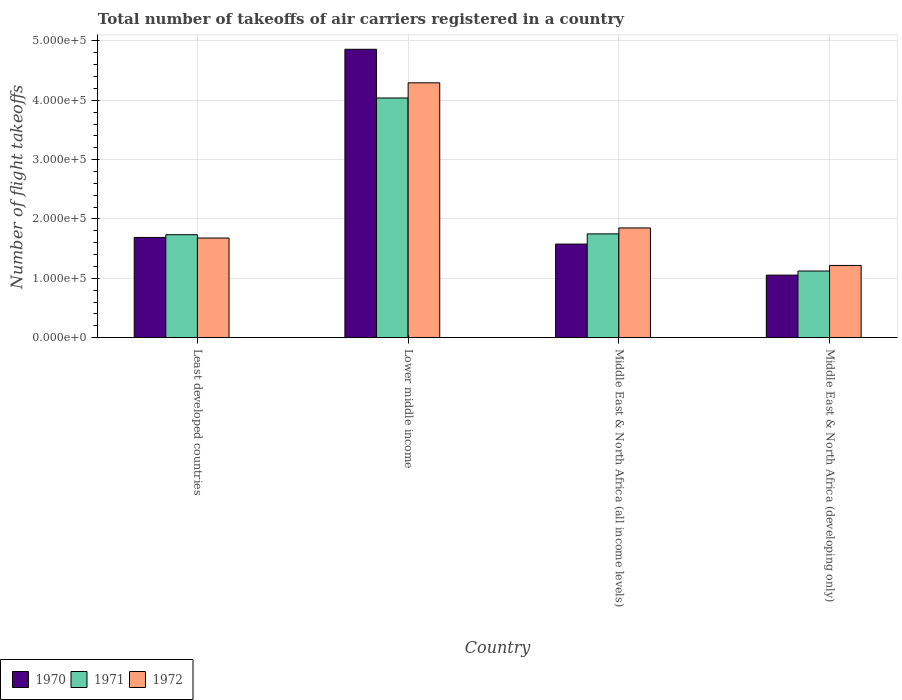Are the number of bars per tick equal to the number of legend labels?
Offer a terse response. Yes. Are the number of bars on each tick of the X-axis equal?
Offer a terse response. Yes. How many bars are there on the 2nd tick from the left?
Your answer should be very brief. 3. How many bars are there on the 1st tick from the right?
Offer a terse response. 3. What is the label of the 1st group of bars from the left?
Your answer should be very brief. Least developed countries. What is the total number of flight takeoffs in 1971 in Least developed countries?
Your answer should be very brief. 1.74e+05. Across all countries, what is the maximum total number of flight takeoffs in 1972?
Provide a short and direct response. 4.30e+05. Across all countries, what is the minimum total number of flight takeoffs in 1971?
Provide a succinct answer. 1.12e+05. In which country was the total number of flight takeoffs in 1972 maximum?
Your answer should be very brief. Lower middle income. In which country was the total number of flight takeoffs in 1970 minimum?
Keep it short and to the point. Middle East & North Africa (developing only). What is the total total number of flight takeoffs in 1970 in the graph?
Offer a terse response. 9.18e+05. What is the difference between the total number of flight takeoffs in 1971 in Middle East & North Africa (all income levels) and that in Middle East & North Africa (developing only)?
Provide a short and direct response. 6.26e+04. What is the difference between the total number of flight takeoffs in 1971 in Middle East & North Africa (developing only) and the total number of flight takeoffs in 1970 in Lower middle income?
Your answer should be very brief. -3.74e+05. What is the average total number of flight takeoffs in 1971 per country?
Keep it short and to the point. 2.16e+05. What is the difference between the total number of flight takeoffs of/in 1970 and total number of flight takeoffs of/in 1972 in Middle East & North Africa (all income levels)?
Provide a succinct answer. -2.72e+04. What is the ratio of the total number of flight takeoffs in 1970 in Lower middle income to that in Middle East & North Africa (all income levels)?
Offer a terse response. 3.08. Is the total number of flight takeoffs in 1972 in Least developed countries less than that in Middle East & North Africa (developing only)?
Offer a terse response. No. Is the difference between the total number of flight takeoffs in 1970 in Lower middle income and Middle East & North Africa (developing only) greater than the difference between the total number of flight takeoffs in 1972 in Lower middle income and Middle East & North Africa (developing only)?
Offer a very short reply. Yes. What is the difference between the highest and the second highest total number of flight takeoffs in 1970?
Your response must be concise. 3.17e+05. What is the difference between the highest and the lowest total number of flight takeoffs in 1970?
Give a very brief answer. 3.81e+05. In how many countries, is the total number of flight takeoffs in 1970 greater than the average total number of flight takeoffs in 1970 taken over all countries?
Your answer should be very brief. 1. Is the sum of the total number of flight takeoffs in 1971 in Lower middle income and Middle East & North Africa (all income levels) greater than the maximum total number of flight takeoffs in 1970 across all countries?
Your answer should be compact. Yes. What does the 3rd bar from the right in Least developed countries represents?
Offer a very short reply. 1970. Is it the case that in every country, the sum of the total number of flight takeoffs in 1971 and total number of flight takeoffs in 1970 is greater than the total number of flight takeoffs in 1972?
Your response must be concise. Yes. How many bars are there?
Your response must be concise. 12. What is the difference between two consecutive major ticks on the Y-axis?
Provide a short and direct response. 1.00e+05. Are the values on the major ticks of Y-axis written in scientific E-notation?
Make the answer very short. Yes. Does the graph contain any zero values?
Offer a terse response. No. Does the graph contain grids?
Your answer should be very brief. Yes. Where does the legend appear in the graph?
Make the answer very short. Bottom left. How many legend labels are there?
Provide a short and direct response. 3. How are the legend labels stacked?
Give a very brief answer. Horizontal. What is the title of the graph?
Make the answer very short. Total number of takeoffs of air carriers registered in a country. What is the label or title of the X-axis?
Offer a terse response. Country. What is the label or title of the Y-axis?
Provide a short and direct response. Number of flight takeoffs. What is the Number of flight takeoffs in 1970 in Least developed countries?
Offer a terse response. 1.69e+05. What is the Number of flight takeoffs in 1971 in Least developed countries?
Your answer should be very brief. 1.74e+05. What is the Number of flight takeoffs of 1972 in Least developed countries?
Offer a very short reply. 1.68e+05. What is the Number of flight takeoffs in 1970 in Lower middle income?
Give a very brief answer. 4.86e+05. What is the Number of flight takeoffs of 1971 in Lower middle income?
Make the answer very short. 4.04e+05. What is the Number of flight takeoffs of 1972 in Lower middle income?
Give a very brief answer. 4.30e+05. What is the Number of flight takeoffs of 1970 in Middle East & North Africa (all income levels)?
Keep it short and to the point. 1.58e+05. What is the Number of flight takeoffs of 1971 in Middle East & North Africa (all income levels)?
Make the answer very short. 1.75e+05. What is the Number of flight takeoffs in 1972 in Middle East & North Africa (all income levels)?
Keep it short and to the point. 1.85e+05. What is the Number of flight takeoffs in 1970 in Middle East & North Africa (developing only)?
Ensure brevity in your answer.  1.05e+05. What is the Number of flight takeoffs in 1971 in Middle East & North Africa (developing only)?
Ensure brevity in your answer.  1.12e+05. What is the Number of flight takeoffs of 1972 in Middle East & North Africa (developing only)?
Give a very brief answer. 1.22e+05. Across all countries, what is the maximum Number of flight takeoffs in 1970?
Your answer should be compact. 4.86e+05. Across all countries, what is the maximum Number of flight takeoffs in 1971?
Your answer should be compact. 4.04e+05. Across all countries, what is the maximum Number of flight takeoffs of 1972?
Provide a short and direct response. 4.30e+05. Across all countries, what is the minimum Number of flight takeoffs of 1970?
Give a very brief answer. 1.05e+05. Across all countries, what is the minimum Number of flight takeoffs in 1971?
Provide a succinct answer. 1.12e+05. Across all countries, what is the minimum Number of flight takeoffs in 1972?
Your answer should be very brief. 1.22e+05. What is the total Number of flight takeoffs in 1970 in the graph?
Keep it short and to the point. 9.18e+05. What is the total Number of flight takeoffs in 1971 in the graph?
Ensure brevity in your answer.  8.65e+05. What is the total Number of flight takeoffs in 1972 in the graph?
Ensure brevity in your answer.  9.04e+05. What is the difference between the Number of flight takeoffs in 1970 in Least developed countries and that in Lower middle income?
Make the answer very short. -3.17e+05. What is the difference between the Number of flight takeoffs in 1971 in Least developed countries and that in Lower middle income?
Keep it short and to the point. -2.30e+05. What is the difference between the Number of flight takeoffs in 1972 in Least developed countries and that in Lower middle income?
Give a very brief answer. -2.62e+05. What is the difference between the Number of flight takeoffs in 1970 in Least developed countries and that in Middle East & North Africa (all income levels)?
Keep it short and to the point. 1.12e+04. What is the difference between the Number of flight takeoffs in 1971 in Least developed countries and that in Middle East & North Africa (all income levels)?
Your response must be concise. -1400. What is the difference between the Number of flight takeoffs in 1972 in Least developed countries and that in Middle East & North Africa (all income levels)?
Offer a very short reply. -1.70e+04. What is the difference between the Number of flight takeoffs of 1970 in Least developed countries and that in Middle East & North Africa (developing only)?
Provide a succinct answer. 6.35e+04. What is the difference between the Number of flight takeoffs in 1971 in Least developed countries and that in Middle East & North Africa (developing only)?
Give a very brief answer. 6.12e+04. What is the difference between the Number of flight takeoffs in 1972 in Least developed countries and that in Middle East & North Africa (developing only)?
Your answer should be very brief. 4.62e+04. What is the difference between the Number of flight takeoffs of 1970 in Lower middle income and that in Middle East & North Africa (all income levels)?
Make the answer very short. 3.28e+05. What is the difference between the Number of flight takeoffs in 1971 in Lower middle income and that in Middle East & North Africa (all income levels)?
Ensure brevity in your answer.  2.29e+05. What is the difference between the Number of flight takeoffs in 1972 in Lower middle income and that in Middle East & North Africa (all income levels)?
Provide a short and direct response. 2.45e+05. What is the difference between the Number of flight takeoffs in 1970 in Lower middle income and that in Middle East & North Africa (developing only)?
Make the answer very short. 3.81e+05. What is the difference between the Number of flight takeoffs of 1971 in Lower middle income and that in Middle East & North Africa (developing only)?
Make the answer very short. 2.92e+05. What is the difference between the Number of flight takeoffs in 1972 in Lower middle income and that in Middle East & North Africa (developing only)?
Your answer should be very brief. 3.08e+05. What is the difference between the Number of flight takeoffs in 1970 in Middle East & North Africa (all income levels) and that in Middle East & North Africa (developing only)?
Your answer should be compact. 5.23e+04. What is the difference between the Number of flight takeoffs in 1971 in Middle East & North Africa (all income levels) and that in Middle East & North Africa (developing only)?
Ensure brevity in your answer.  6.26e+04. What is the difference between the Number of flight takeoffs in 1972 in Middle East & North Africa (all income levels) and that in Middle East & North Africa (developing only)?
Your answer should be compact. 6.32e+04. What is the difference between the Number of flight takeoffs in 1970 in Least developed countries and the Number of flight takeoffs in 1971 in Lower middle income?
Your response must be concise. -2.35e+05. What is the difference between the Number of flight takeoffs of 1970 in Least developed countries and the Number of flight takeoffs of 1972 in Lower middle income?
Ensure brevity in your answer.  -2.61e+05. What is the difference between the Number of flight takeoffs in 1971 in Least developed countries and the Number of flight takeoffs in 1972 in Lower middle income?
Provide a short and direct response. -2.56e+05. What is the difference between the Number of flight takeoffs of 1970 in Least developed countries and the Number of flight takeoffs of 1971 in Middle East & North Africa (all income levels)?
Make the answer very short. -6000. What is the difference between the Number of flight takeoffs in 1970 in Least developed countries and the Number of flight takeoffs in 1972 in Middle East & North Africa (all income levels)?
Offer a terse response. -1.60e+04. What is the difference between the Number of flight takeoffs in 1971 in Least developed countries and the Number of flight takeoffs in 1972 in Middle East & North Africa (all income levels)?
Your answer should be compact. -1.14e+04. What is the difference between the Number of flight takeoffs of 1970 in Least developed countries and the Number of flight takeoffs of 1971 in Middle East & North Africa (developing only)?
Offer a very short reply. 5.66e+04. What is the difference between the Number of flight takeoffs in 1970 in Least developed countries and the Number of flight takeoffs in 1972 in Middle East & North Africa (developing only)?
Your answer should be compact. 4.72e+04. What is the difference between the Number of flight takeoffs of 1971 in Least developed countries and the Number of flight takeoffs of 1972 in Middle East & North Africa (developing only)?
Your response must be concise. 5.18e+04. What is the difference between the Number of flight takeoffs in 1970 in Lower middle income and the Number of flight takeoffs in 1971 in Middle East & North Africa (all income levels)?
Ensure brevity in your answer.  3.11e+05. What is the difference between the Number of flight takeoffs in 1970 in Lower middle income and the Number of flight takeoffs in 1972 in Middle East & North Africa (all income levels)?
Keep it short and to the point. 3.01e+05. What is the difference between the Number of flight takeoffs of 1971 in Lower middle income and the Number of flight takeoffs of 1972 in Middle East & North Africa (all income levels)?
Offer a terse response. 2.19e+05. What is the difference between the Number of flight takeoffs of 1970 in Lower middle income and the Number of flight takeoffs of 1971 in Middle East & North Africa (developing only)?
Ensure brevity in your answer.  3.74e+05. What is the difference between the Number of flight takeoffs in 1970 in Lower middle income and the Number of flight takeoffs in 1972 in Middle East & North Africa (developing only)?
Keep it short and to the point. 3.64e+05. What is the difference between the Number of flight takeoffs in 1971 in Lower middle income and the Number of flight takeoffs in 1972 in Middle East & North Africa (developing only)?
Make the answer very short. 2.82e+05. What is the difference between the Number of flight takeoffs in 1970 in Middle East & North Africa (all income levels) and the Number of flight takeoffs in 1971 in Middle East & North Africa (developing only)?
Provide a succinct answer. 4.54e+04. What is the difference between the Number of flight takeoffs of 1970 in Middle East & North Africa (all income levels) and the Number of flight takeoffs of 1972 in Middle East & North Africa (developing only)?
Your answer should be compact. 3.60e+04. What is the difference between the Number of flight takeoffs in 1971 in Middle East & North Africa (all income levels) and the Number of flight takeoffs in 1972 in Middle East & North Africa (developing only)?
Keep it short and to the point. 5.32e+04. What is the average Number of flight takeoffs of 1970 per country?
Your response must be concise. 2.30e+05. What is the average Number of flight takeoffs of 1971 per country?
Your answer should be very brief. 2.16e+05. What is the average Number of flight takeoffs of 1972 per country?
Your answer should be compact. 2.26e+05. What is the difference between the Number of flight takeoffs of 1970 and Number of flight takeoffs of 1971 in Least developed countries?
Provide a succinct answer. -4600. What is the difference between the Number of flight takeoffs in 1970 and Number of flight takeoffs in 1972 in Least developed countries?
Your answer should be very brief. 1000. What is the difference between the Number of flight takeoffs in 1971 and Number of flight takeoffs in 1972 in Least developed countries?
Give a very brief answer. 5600. What is the difference between the Number of flight takeoffs in 1970 and Number of flight takeoffs in 1971 in Lower middle income?
Make the answer very short. 8.21e+04. What is the difference between the Number of flight takeoffs of 1970 and Number of flight takeoffs of 1972 in Lower middle income?
Provide a succinct answer. 5.65e+04. What is the difference between the Number of flight takeoffs in 1971 and Number of flight takeoffs in 1972 in Lower middle income?
Keep it short and to the point. -2.56e+04. What is the difference between the Number of flight takeoffs of 1970 and Number of flight takeoffs of 1971 in Middle East & North Africa (all income levels)?
Give a very brief answer. -1.72e+04. What is the difference between the Number of flight takeoffs of 1970 and Number of flight takeoffs of 1972 in Middle East & North Africa (all income levels)?
Give a very brief answer. -2.72e+04. What is the difference between the Number of flight takeoffs in 1971 and Number of flight takeoffs in 1972 in Middle East & North Africa (all income levels)?
Your answer should be compact. -10000. What is the difference between the Number of flight takeoffs in 1970 and Number of flight takeoffs in 1971 in Middle East & North Africa (developing only)?
Provide a succinct answer. -6900. What is the difference between the Number of flight takeoffs in 1970 and Number of flight takeoffs in 1972 in Middle East & North Africa (developing only)?
Keep it short and to the point. -1.63e+04. What is the difference between the Number of flight takeoffs in 1971 and Number of flight takeoffs in 1972 in Middle East & North Africa (developing only)?
Offer a terse response. -9400. What is the ratio of the Number of flight takeoffs in 1970 in Least developed countries to that in Lower middle income?
Your response must be concise. 0.35. What is the ratio of the Number of flight takeoffs in 1971 in Least developed countries to that in Lower middle income?
Your response must be concise. 0.43. What is the ratio of the Number of flight takeoffs in 1972 in Least developed countries to that in Lower middle income?
Ensure brevity in your answer.  0.39. What is the ratio of the Number of flight takeoffs of 1970 in Least developed countries to that in Middle East & North Africa (all income levels)?
Offer a very short reply. 1.07. What is the ratio of the Number of flight takeoffs of 1972 in Least developed countries to that in Middle East & North Africa (all income levels)?
Your answer should be compact. 0.91. What is the ratio of the Number of flight takeoffs of 1970 in Least developed countries to that in Middle East & North Africa (developing only)?
Your response must be concise. 1.6. What is the ratio of the Number of flight takeoffs in 1971 in Least developed countries to that in Middle East & North Africa (developing only)?
Provide a succinct answer. 1.54. What is the ratio of the Number of flight takeoffs in 1972 in Least developed countries to that in Middle East & North Africa (developing only)?
Offer a very short reply. 1.38. What is the ratio of the Number of flight takeoffs in 1970 in Lower middle income to that in Middle East & North Africa (all income levels)?
Make the answer very short. 3.08. What is the ratio of the Number of flight takeoffs of 1971 in Lower middle income to that in Middle East & North Africa (all income levels)?
Provide a succinct answer. 2.31. What is the ratio of the Number of flight takeoffs in 1972 in Lower middle income to that in Middle East & North Africa (all income levels)?
Provide a succinct answer. 2.32. What is the ratio of the Number of flight takeoffs of 1970 in Lower middle income to that in Middle East & North Africa (developing only)?
Give a very brief answer. 4.61. What is the ratio of the Number of flight takeoffs of 1971 in Lower middle income to that in Middle East & North Africa (developing only)?
Offer a terse response. 3.6. What is the ratio of the Number of flight takeoffs of 1972 in Lower middle income to that in Middle East & North Africa (developing only)?
Keep it short and to the point. 3.53. What is the ratio of the Number of flight takeoffs of 1970 in Middle East & North Africa (all income levels) to that in Middle East & North Africa (developing only)?
Offer a terse response. 1.5. What is the ratio of the Number of flight takeoffs in 1971 in Middle East & North Africa (all income levels) to that in Middle East & North Africa (developing only)?
Offer a terse response. 1.56. What is the ratio of the Number of flight takeoffs of 1972 in Middle East & North Africa (all income levels) to that in Middle East & North Africa (developing only)?
Provide a succinct answer. 1.52. What is the difference between the highest and the second highest Number of flight takeoffs in 1970?
Make the answer very short. 3.17e+05. What is the difference between the highest and the second highest Number of flight takeoffs in 1971?
Your answer should be very brief. 2.29e+05. What is the difference between the highest and the second highest Number of flight takeoffs of 1972?
Provide a succinct answer. 2.45e+05. What is the difference between the highest and the lowest Number of flight takeoffs in 1970?
Provide a short and direct response. 3.81e+05. What is the difference between the highest and the lowest Number of flight takeoffs in 1971?
Offer a terse response. 2.92e+05. What is the difference between the highest and the lowest Number of flight takeoffs in 1972?
Your answer should be compact. 3.08e+05. 